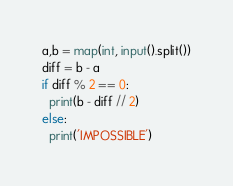Convert code to text. <code><loc_0><loc_0><loc_500><loc_500><_Python_>a,b = map(int, input().split())
diff = b - a 
if diff % 2 == 0:
  print(b - diff // 2)
else:
  print('IMPOSSIBLE')</code> 